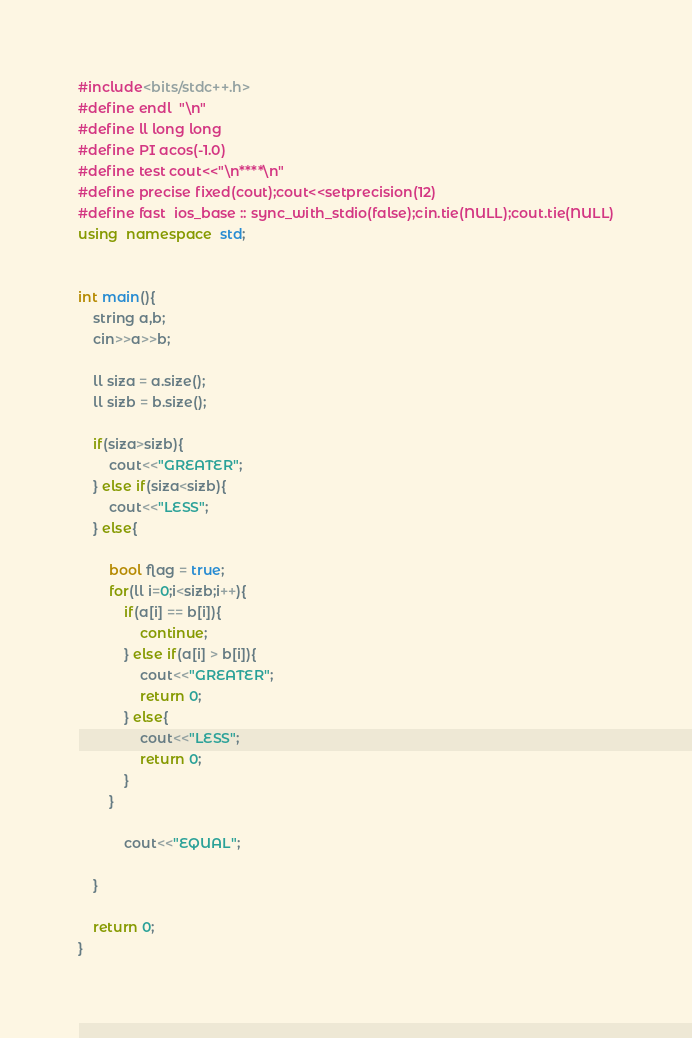<code> <loc_0><loc_0><loc_500><loc_500><_C++_>#include<bits/stdc++.h>
#define endl  "\n"
#define ll long long
#define PI acos(-1.0)
#define test cout<<"\n****\n"
#define precise fixed(cout);cout<<setprecision(12)
#define fast  ios_base :: sync_with_stdio(false);cin.tie(NULL);cout.tie(NULL)
using  namespace  std;


int main(){
    string a,b;
    cin>>a>>b;

    ll siza = a.size();
    ll sizb = b.size();

    if(siza>sizb){
        cout<<"GREATER";
    } else if(siza<sizb){
        cout<<"LESS";
    } else{

        bool flag = true;
        for(ll i=0;i<sizb;i++){
            if(a[i] == b[i]){
                continue;
            } else if(a[i] > b[i]){
                cout<<"GREATER";
                return 0;
            } else{
                cout<<"LESS";
                return 0;
            }
        }
        
            cout<<"EQUAL";
        
    }
    
    return 0;
}
</code> 